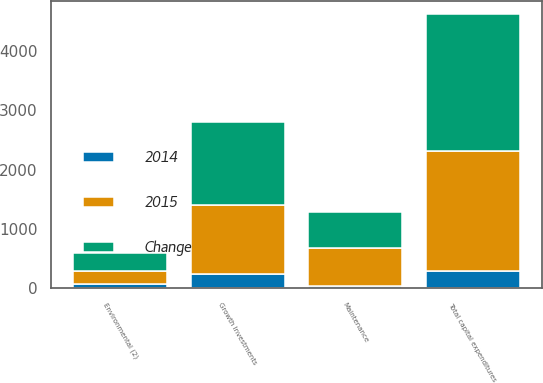Convert chart to OTSL. <chart><loc_0><loc_0><loc_500><loc_500><stacked_bar_chart><ecel><fcel>Growth Investments<fcel>Maintenance<fcel>Environmental (2)<fcel>Total capital expenditures<nl><fcel>Change<fcel>1401<fcel>606<fcel>301<fcel>2308<nl><fcel>2015<fcel>1151<fcel>645<fcel>220<fcel>2016<nl><fcel>2014<fcel>250<fcel>39<fcel>81<fcel>292<nl></chart> 